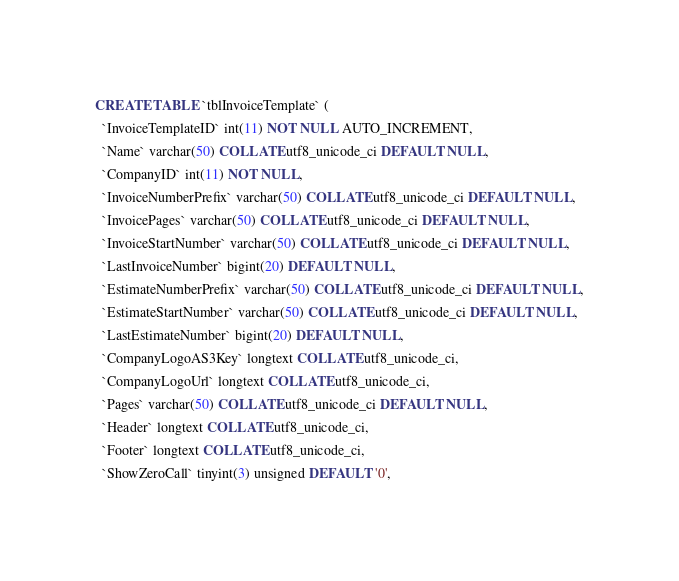<code> <loc_0><loc_0><loc_500><loc_500><_SQL_>CREATE TABLE `tblInvoiceTemplate` (
  `InvoiceTemplateID` int(11) NOT NULL AUTO_INCREMENT,
  `Name` varchar(50) COLLATE utf8_unicode_ci DEFAULT NULL,
  `CompanyID` int(11) NOT NULL,
  `InvoiceNumberPrefix` varchar(50) COLLATE utf8_unicode_ci DEFAULT NULL,
  `InvoicePages` varchar(50) COLLATE utf8_unicode_ci DEFAULT NULL,
  `InvoiceStartNumber` varchar(50) COLLATE utf8_unicode_ci DEFAULT NULL,
  `LastInvoiceNumber` bigint(20) DEFAULT NULL,
  `EstimateNumberPrefix` varchar(50) COLLATE utf8_unicode_ci DEFAULT NULL,
  `EstimateStartNumber` varchar(50) COLLATE utf8_unicode_ci DEFAULT NULL,
  `LastEstimateNumber` bigint(20) DEFAULT NULL,
  `CompanyLogoAS3Key` longtext COLLATE utf8_unicode_ci,
  `CompanyLogoUrl` longtext COLLATE utf8_unicode_ci,
  `Pages` varchar(50) COLLATE utf8_unicode_ci DEFAULT NULL,
  `Header` longtext COLLATE utf8_unicode_ci,
  `Footer` longtext COLLATE utf8_unicode_ci,
  `ShowZeroCall` tinyint(3) unsigned DEFAULT '0',</code> 